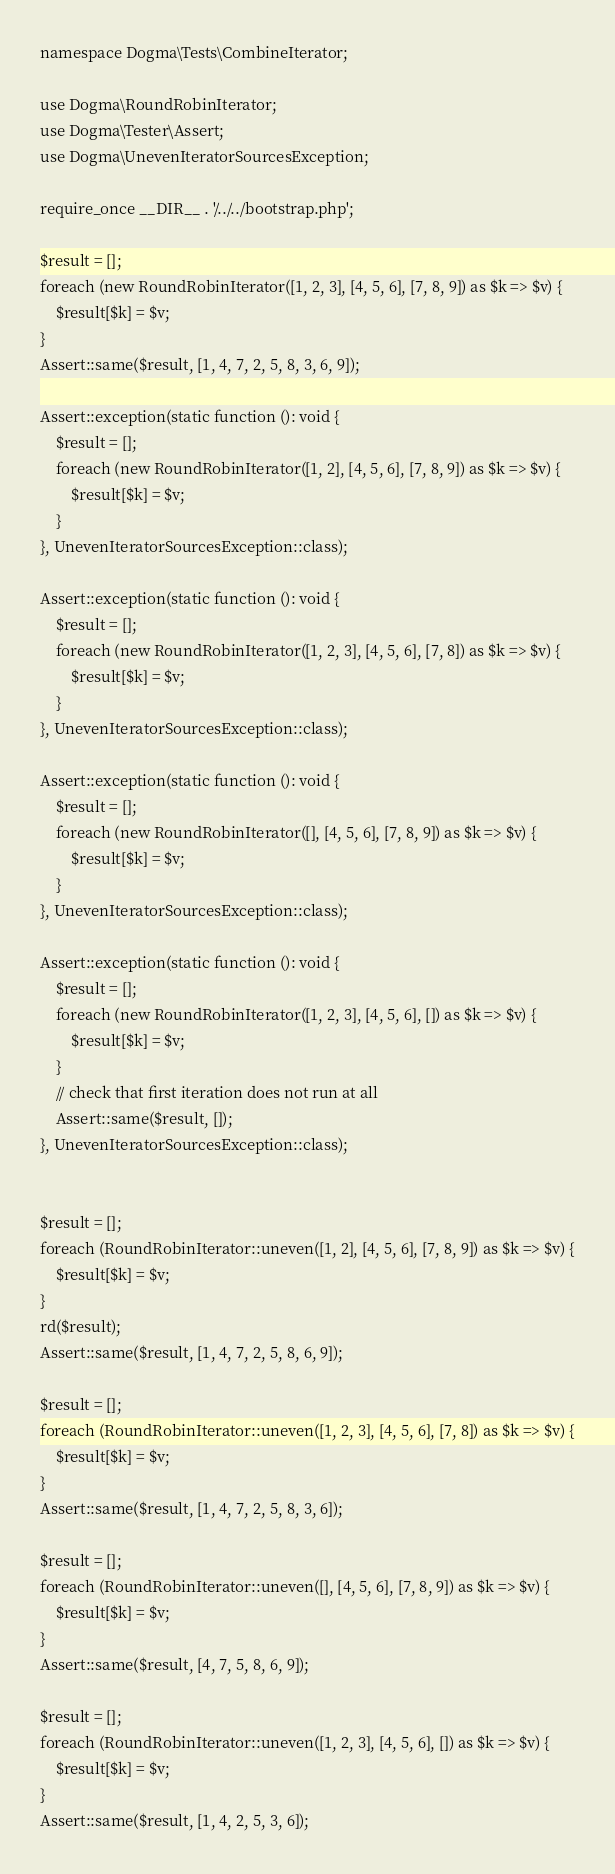<code> <loc_0><loc_0><loc_500><loc_500><_PHP_>namespace Dogma\Tests\CombineIterator;

use Dogma\RoundRobinIterator;
use Dogma\Tester\Assert;
use Dogma\UnevenIteratorSourcesException;

require_once __DIR__ . '/../../bootstrap.php';

$result = [];
foreach (new RoundRobinIterator([1, 2, 3], [4, 5, 6], [7, 8, 9]) as $k => $v) {
    $result[$k] = $v;
}
Assert::same($result, [1, 4, 7, 2, 5, 8, 3, 6, 9]);

Assert::exception(static function (): void {
    $result = [];
    foreach (new RoundRobinIterator([1, 2], [4, 5, 6], [7, 8, 9]) as $k => $v) {
        $result[$k] = $v;
    }
}, UnevenIteratorSourcesException::class);

Assert::exception(static function (): void {
    $result = [];
    foreach (new RoundRobinIterator([1, 2, 3], [4, 5, 6], [7, 8]) as $k => $v) {
        $result[$k] = $v;
    }
}, UnevenIteratorSourcesException::class);

Assert::exception(static function (): void {
    $result = [];
    foreach (new RoundRobinIterator([], [4, 5, 6], [7, 8, 9]) as $k => $v) {
        $result[$k] = $v;
    }
}, UnevenIteratorSourcesException::class);

Assert::exception(static function (): void {
    $result = [];
    foreach (new RoundRobinIterator([1, 2, 3], [4, 5, 6], []) as $k => $v) {
        $result[$k] = $v;
    }
    // check that first iteration does not run at all
    Assert::same($result, []);
}, UnevenIteratorSourcesException::class);


$result = [];
foreach (RoundRobinIterator::uneven([1, 2], [4, 5, 6], [7, 8, 9]) as $k => $v) {
    $result[$k] = $v;
}
rd($result);
Assert::same($result, [1, 4, 7, 2, 5, 8, 6, 9]);

$result = [];
foreach (RoundRobinIterator::uneven([1, 2, 3], [4, 5, 6], [7, 8]) as $k => $v) {
    $result[$k] = $v;
}
Assert::same($result, [1, 4, 7, 2, 5, 8, 3, 6]);

$result = [];
foreach (RoundRobinIterator::uneven([], [4, 5, 6], [7, 8, 9]) as $k => $v) {
    $result[$k] = $v;
}
Assert::same($result, [4, 7, 5, 8, 6, 9]);

$result = [];
foreach (RoundRobinIterator::uneven([1, 2, 3], [4, 5, 6], []) as $k => $v) {
    $result[$k] = $v;
}
Assert::same($result, [1, 4, 2, 5, 3, 6]);
</code> 